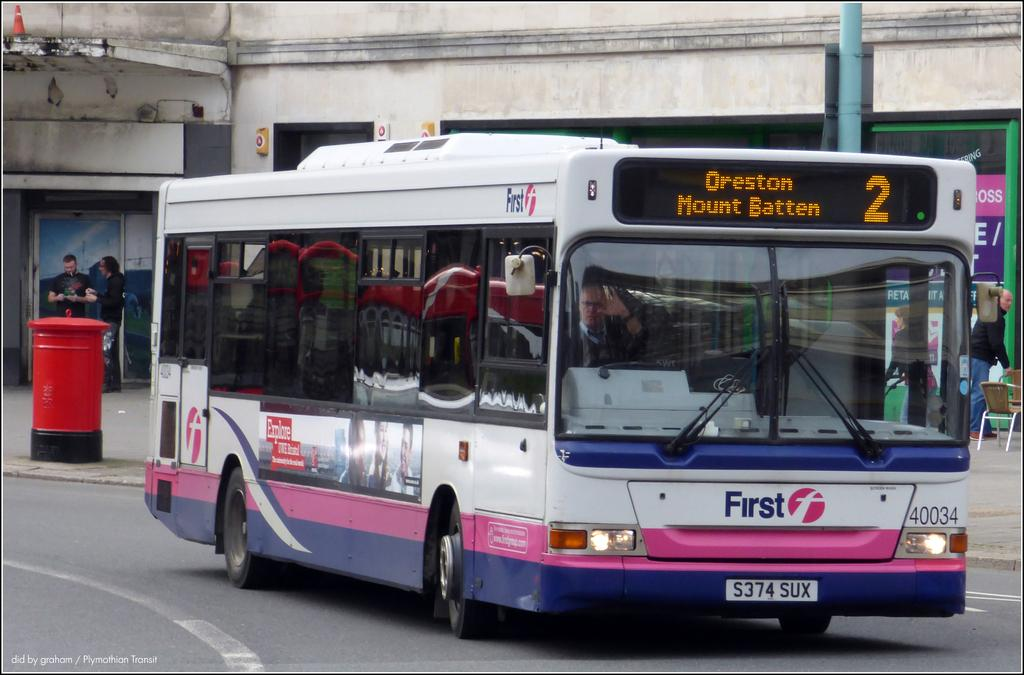<image>
Provide a brief description of the given image. a colorful number 2 bus to Oreston on the street 